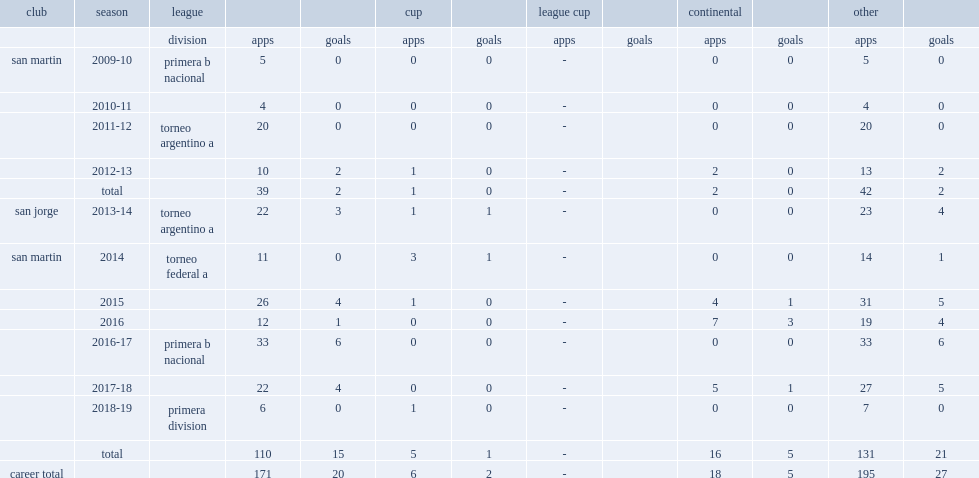How many goals did gonzalo rodriguez score for san jorge in the 2013-14 season? 4.0. 